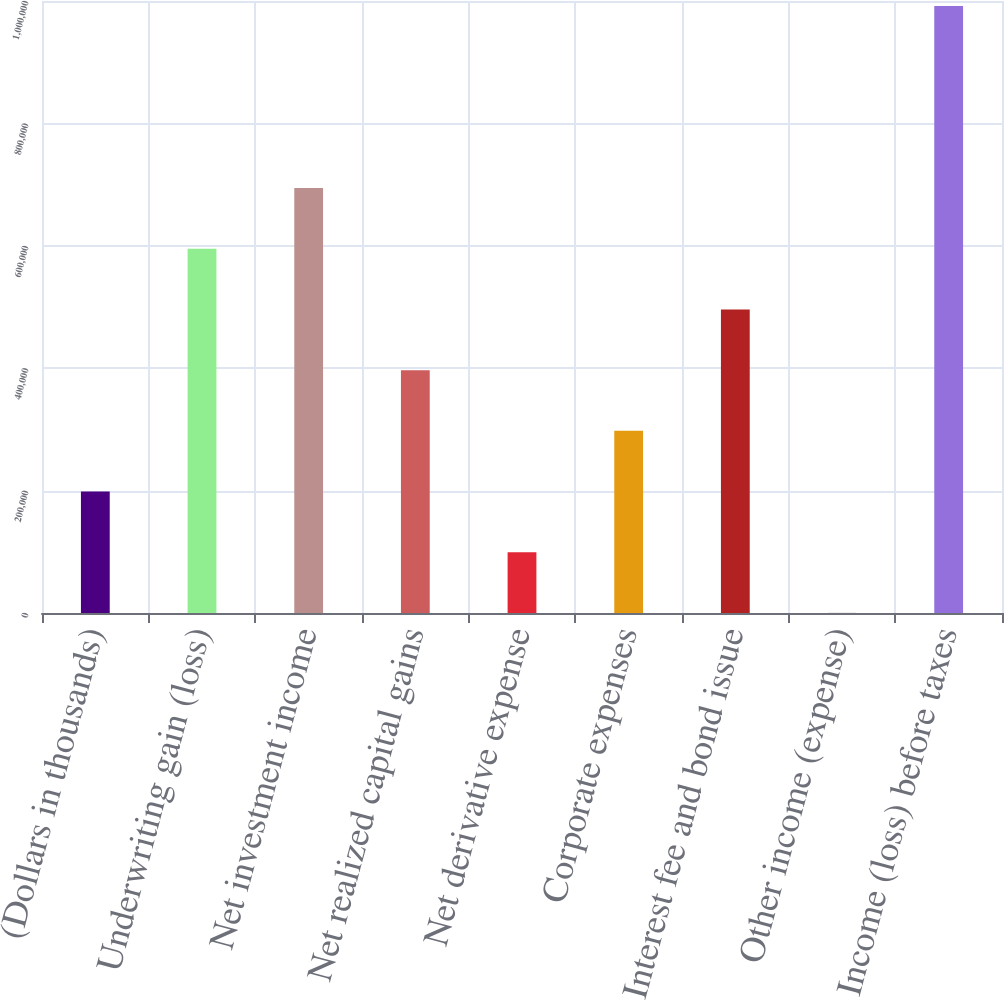Convert chart to OTSL. <chart><loc_0><loc_0><loc_500><loc_500><bar_chart><fcel>(Dollars in thousands)<fcel>Underwriting gain (loss)<fcel>Net investment income<fcel>Net realized capital gains<fcel>Net derivative expense<fcel>Corporate expenses<fcel>Interest fee and bond issue<fcel>Other income (expense)<fcel>Income (loss) before taxes<nl><fcel>198440<fcel>595095<fcel>694259<fcel>396767<fcel>99275.8<fcel>297603<fcel>495931<fcel>112<fcel>991750<nl></chart> 